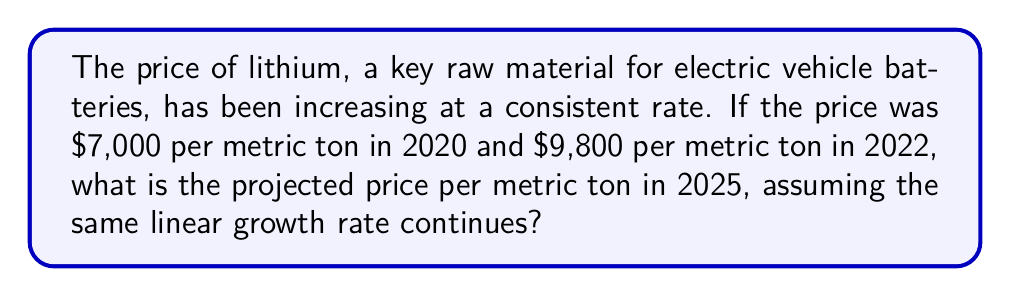Show me your answer to this math problem. Let's approach this step-by-step:

1) First, we need to calculate the annual rate of increase:
   
   Price increase from 2020 to 2022 = $9,800 - $7,000 = $2,800
   Time period = 2 years
   Annual rate of increase = $2,800 ÷ 2 = $1,400 per year

2) We can express this as a linear equation:
   $$P(t) = 7000 + 1400t$$
   where $P(t)$ is the price in dollars and $t$ is the number of years since 2020.

3) To find the price in 2025, we need to calculate for $t = 5$ (as 2025 is 5 years after 2020):
   
   $$P(5) = 7000 + 1400(5)$$

4) Let's solve this equation:
   $$P(5) = 7000 + 7000 = 14000$$

Therefore, the projected price of lithium in 2025 is $14,000 per metric ton.
Answer: $14,000 per metric ton 